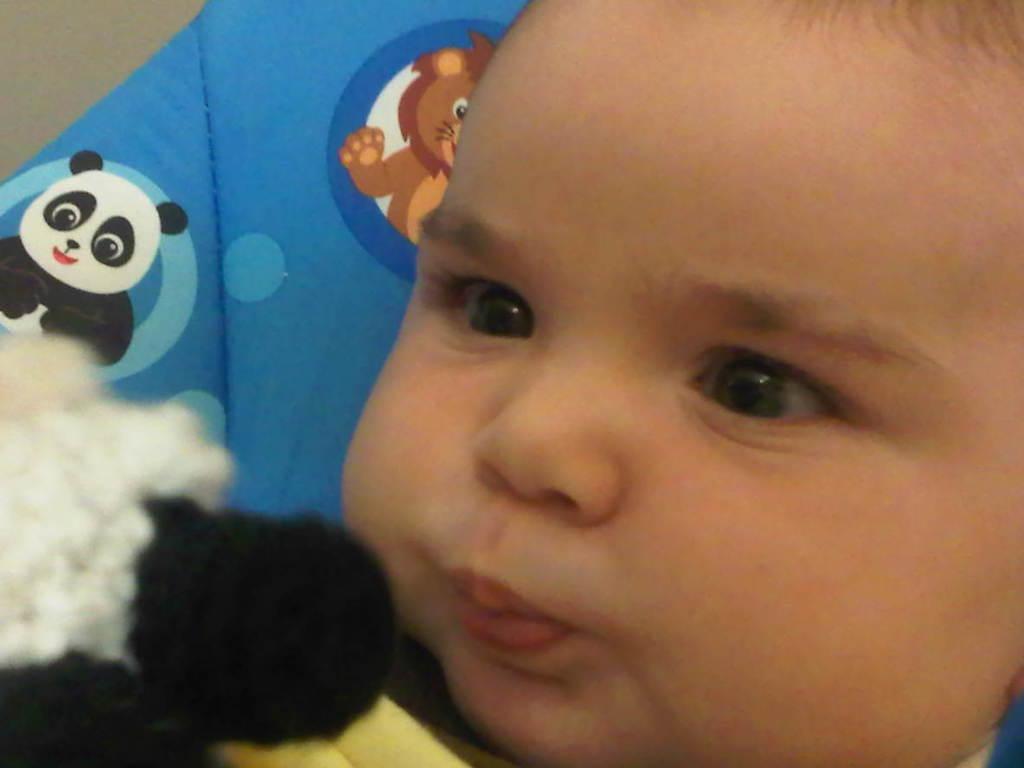Can you describe this image briefly? In this image we can see a baby on a blue surface, there are animal cartoon images present on it. 